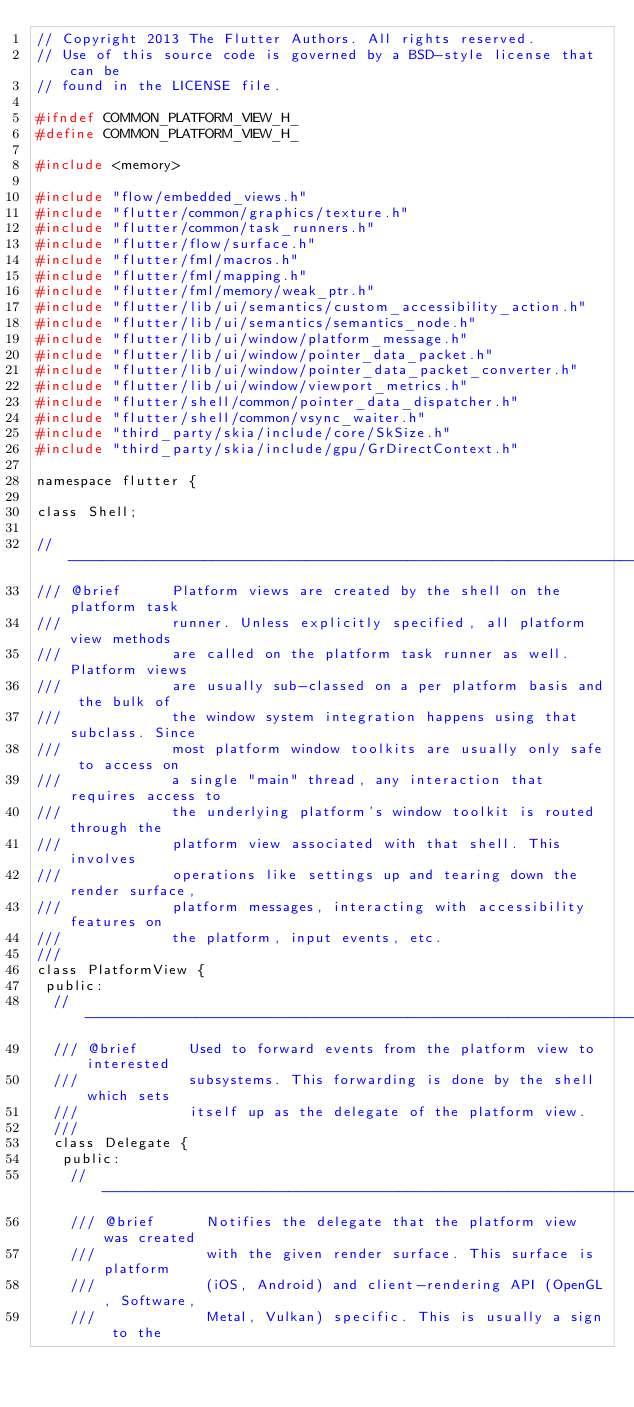<code> <loc_0><loc_0><loc_500><loc_500><_C_>// Copyright 2013 The Flutter Authors. All rights reserved.
// Use of this source code is governed by a BSD-style license that can be
// found in the LICENSE file.

#ifndef COMMON_PLATFORM_VIEW_H_
#define COMMON_PLATFORM_VIEW_H_

#include <memory>

#include "flow/embedded_views.h"
#include "flutter/common/graphics/texture.h"
#include "flutter/common/task_runners.h"
#include "flutter/flow/surface.h"
#include "flutter/fml/macros.h"
#include "flutter/fml/mapping.h"
#include "flutter/fml/memory/weak_ptr.h"
#include "flutter/lib/ui/semantics/custom_accessibility_action.h"
#include "flutter/lib/ui/semantics/semantics_node.h"
#include "flutter/lib/ui/window/platform_message.h"
#include "flutter/lib/ui/window/pointer_data_packet.h"
#include "flutter/lib/ui/window/pointer_data_packet_converter.h"
#include "flutter/lib/ui/window/viewport_metrics.h"
#include "flutter/shell/common/pointer_data_dispatcher.h"
#include "flutter/shell/common/vsync_waiter.h"
#include "third_party/skia/include/core/SkSize.h"
#include "third_party/skia/include/gpu/GrDirectContext.h"

namespace flutter {

class Shell;

//------------------------------------------------------------------------------
/// @brief      Platform views are created by the shell on the platform task
///             runner. Unless explicitly specified, all platform view methods
///             are called on the platform task runner as well. Platform views
///             are usually sub-classed on a per platform basis and the bulk of
///             the window system integration happens using that subclass. Since
///             most platform window toolkits are usually only safe to access on
///             a single "main" thread, any interaction that requires access to
///             the underlying platform's window toolkit is routed through the
///             platform view associated with that shell. This involves
///             operations like settings up and tearing down the render surface,
///             platform messages, interacting with accessibility features on
///             the platform, input events, etc.
///
class PlatformView {
 public:
  //----------------------------------------------------------------------------
  /// @brief      Used to forward events from the platform view to interested
  ///             subsystems. This forwarding is done by the shell which sets
  ///             itself up as the delegate of the platform view.
  ///
  class Delegate {
   public:
    //--------------------------------------------------------------------------
    /// @brief      Notifies the delegate that the platform view was created
    ///             with the given render surface. This surface is platform
    ///             (iOS, Android) and client-rendering API (OpenGL, Software,
    ///             Metal, Vulkan) specific. This is usually a sign to the</code> 